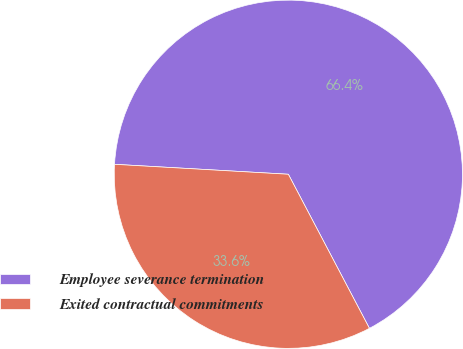<chart> <loc_0><loc_0><loc_500><loc_500><pie_chart><fcel>Employee severance termination<fcel>Exited contractual commitments<nl><fcel>66.38%<fcel>33.62%<nl></chart> 